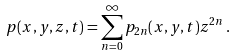Convert formula to latex. <formula><loc_0><loc_0><loc_500><loc_500>p ( x , y , z , t ) = \sum _ { n = 0 } ^ { \infty } p _ { 2 n } ( x , y , t ) z ^ { 2 n } \, .</formula> 